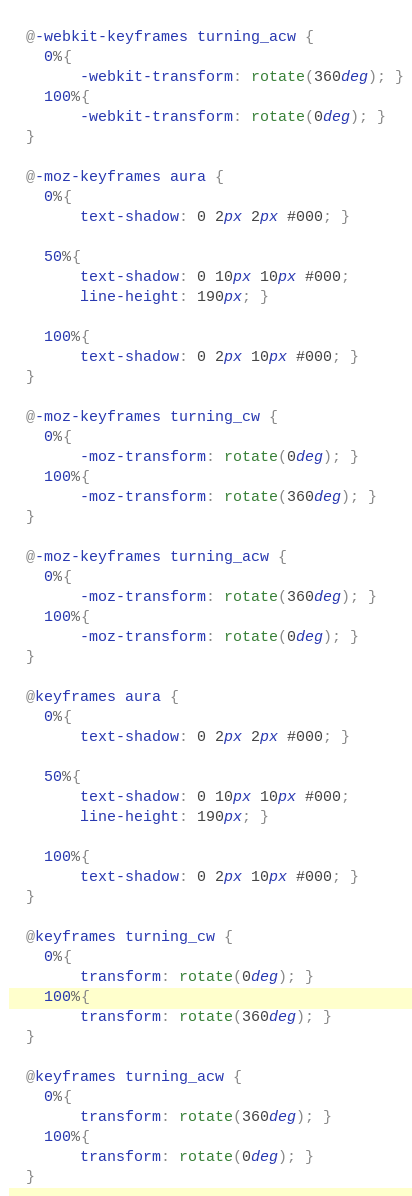<code> <loc_0><loc_0><loc_500><loc_500><_CSS_>  
  @-webkit-keyframes turning_acw {
  	0%{
  		-webkit-transform: rotate(360deg); }
  	100%{
  		-webkit-transform: rotate(0deg); }
  }

  @-moz-keyframes aura {
  	0%{
  		text-shadow: 0 2px 2px #000; }
  		
  	50%{
  		text-shadow: 0 10px 10px #000;
  		line-height: 190px; }
  		
  	100%{
  		text-shadow: 0 2px 10px #000; }
  }

  @-moz-keyframes turning_cw {
  	0%{
  		-moz-transform: rotate(0deg); }
  	100%{
  		-moz-transform: rotate(360deg); }
  }
  
  @-moz-keyframes turning_acw {
  	0%{
  		-moz-transform: rotate(360deg); }
  	100%{
  		-moz-transform: rotate(0deg); }
  }

  @keyframes aura {
  	0%{
  		text-shadow: 0 2px 2px #000; }
  		
  	50%{
  		text-shadow: 0 10px 10px #000;
  		line-height: 190px; }
  		
  	100%{
  		text-shadow: 0 2px 10px #000; }
  }

  @keyframes turning_cw {
  	0%{
  		transform: rotate(0deg); }
  	100%{
  		transform: rotate(360deg); }
  }
  
  @keyframes turning_acw {
  	0%{
  		transform: rotate(360deg); }
  	100%{
  		transform: rotate(0deg); }
  }</code> 